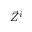<formula> <loc_0><loc_0><loc_500><loc_500>{ \vec { Z } } ^ { i }</formula> 